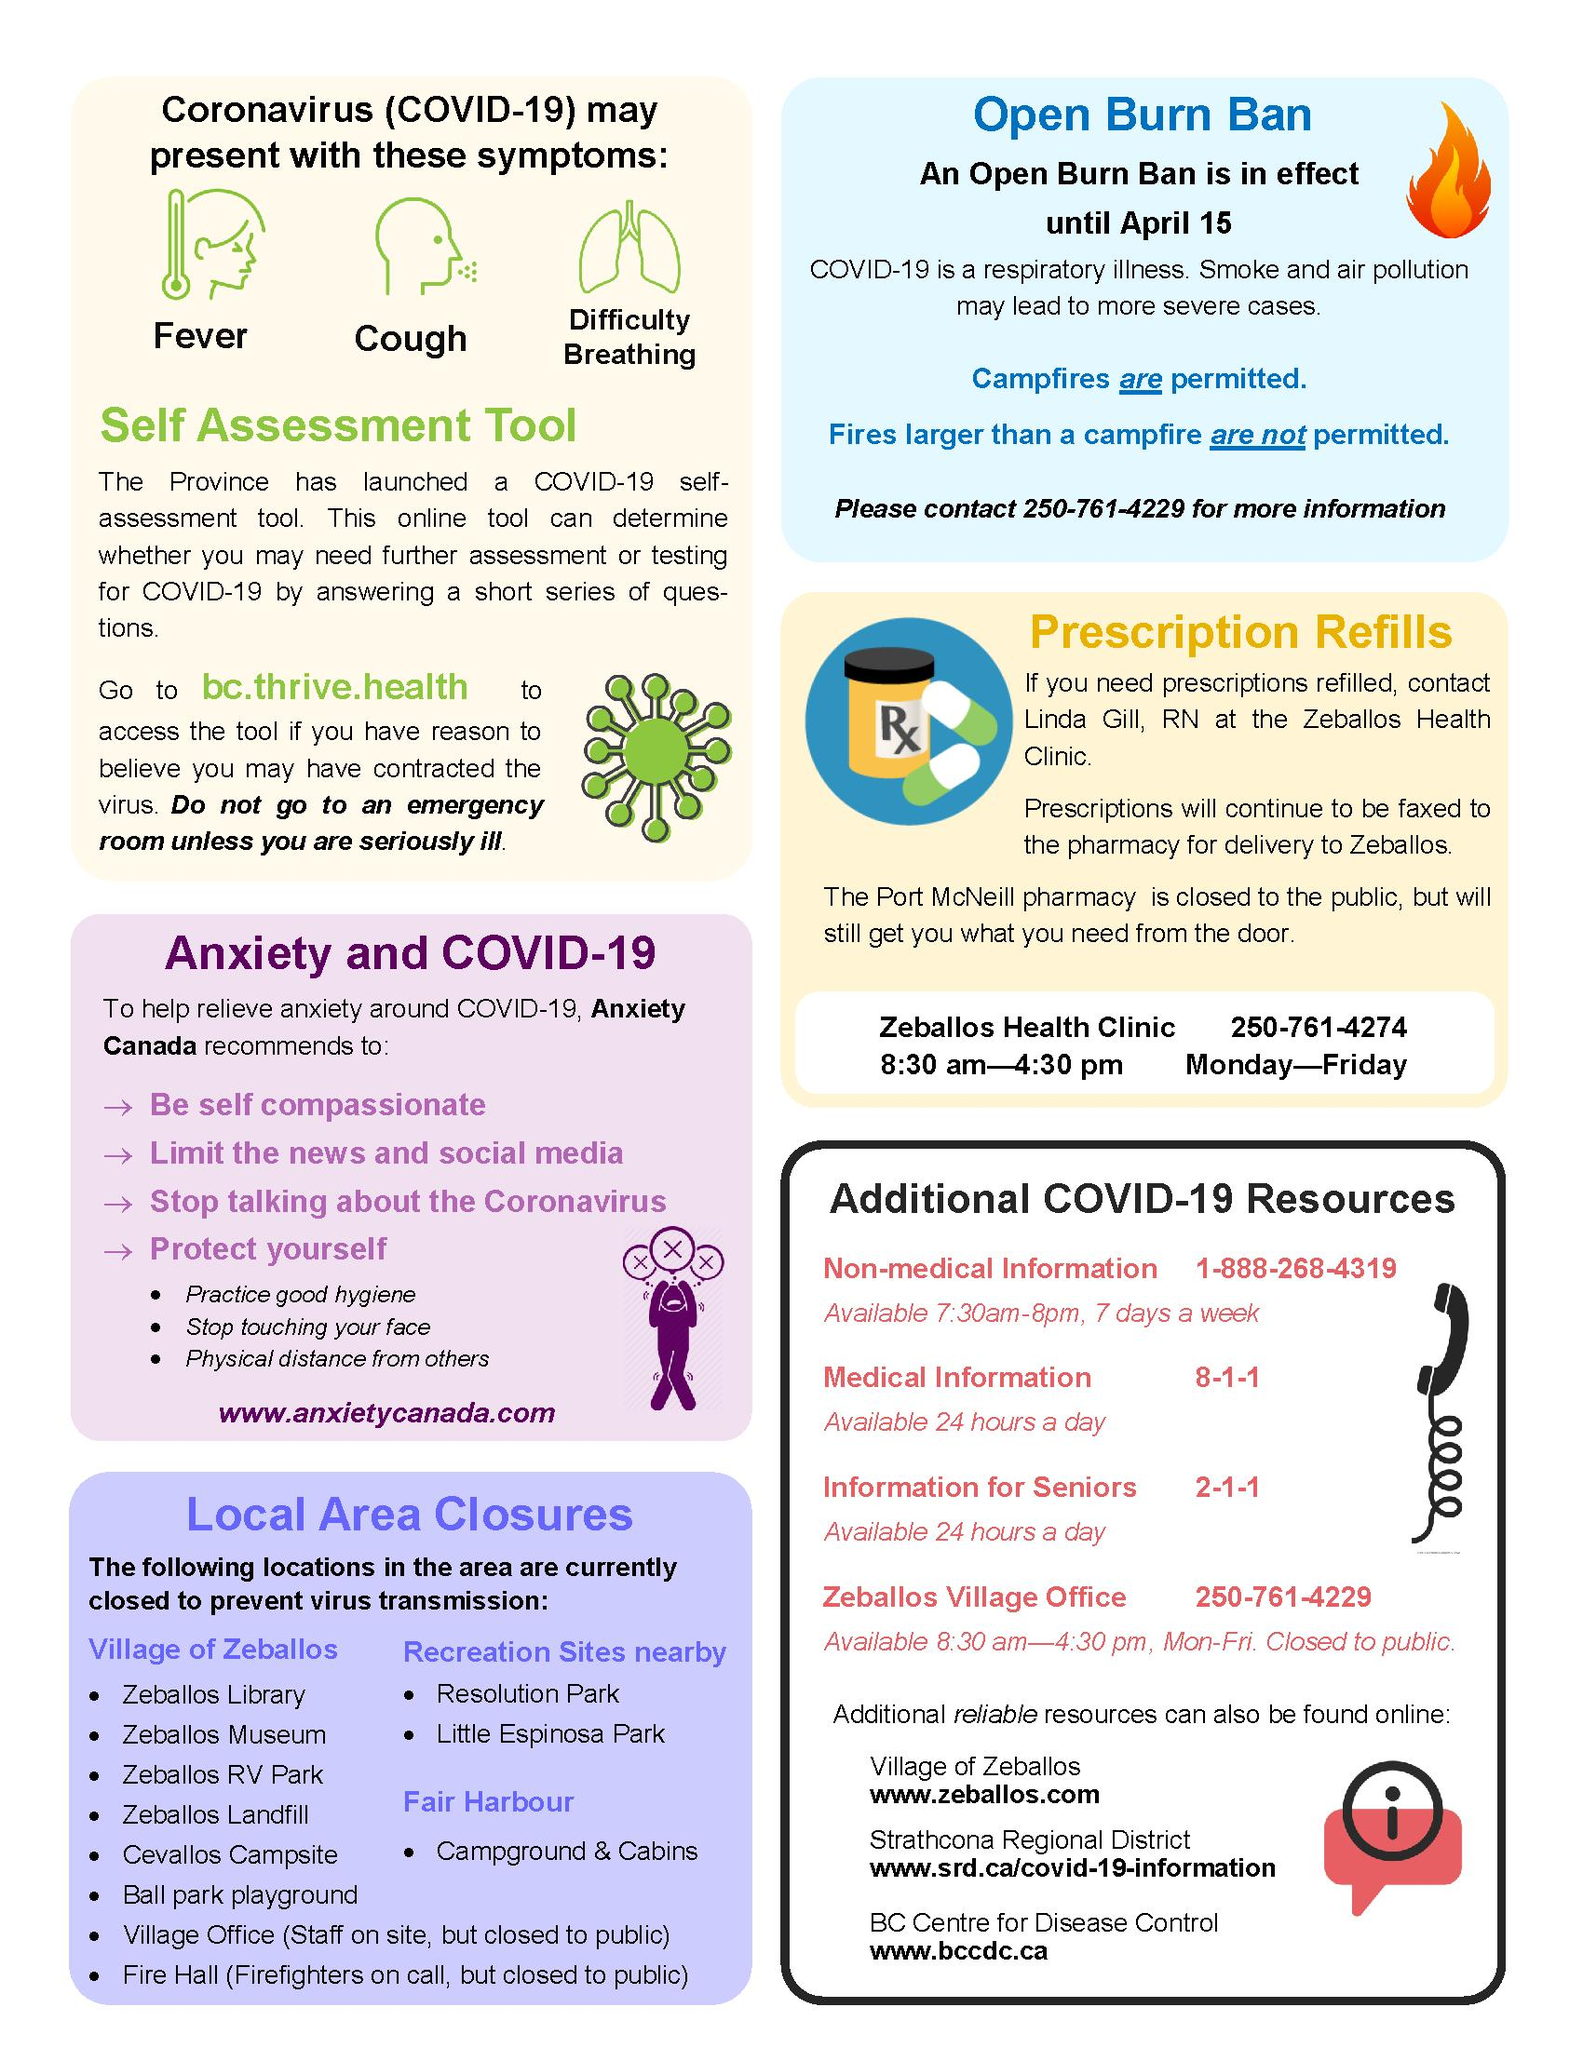Mention a couple of crucial points in this snapshot. The common symptom of COVID-19, other than fever and cough, is difficulty breathing. 